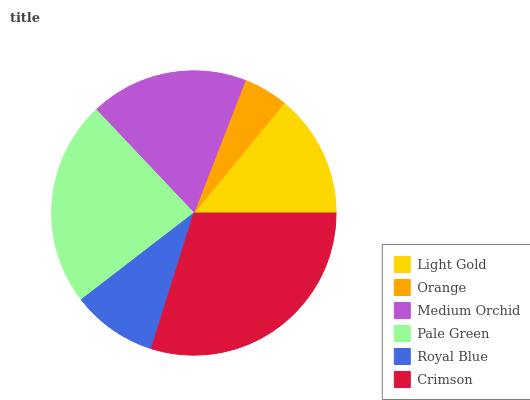Is Orange the minimum?
Answer yes or no. Yes. Is Crimson the maximum?
Answer yes or no. Yes. Is Medium Orchid the minimum?
Answer yes or no. No. Is Medium Orchid the maximum?
Answer yes or no. No. Is Medium Orchid greater than Orange?
Answer yes or no. Yes. Is Orange less than Medium Orchid?
Answer yes or no. Yes. Is Orange greater than Medium Orchid?
Answer yes or no. No. Is Medium Orchid less than Orange?
Answer yes or no. No. Is Medium Orchid the high median?
Answer yes or no. Yes. Is Light Gold the low median?
Answer yes or no. Yes. Is Pale Green the high median?
Answer yes or no. No. Is Crimson the low median?
Answer yes or no. No. 